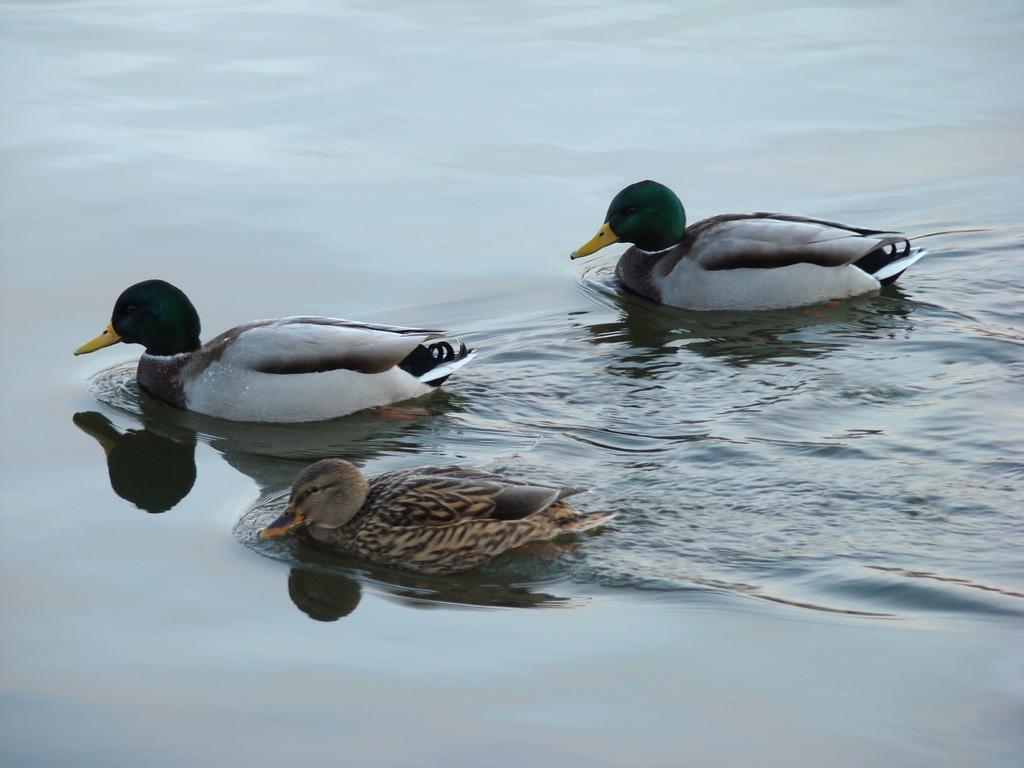Please provide a concise description of this image. In the image there are ducks swimming in the water. 